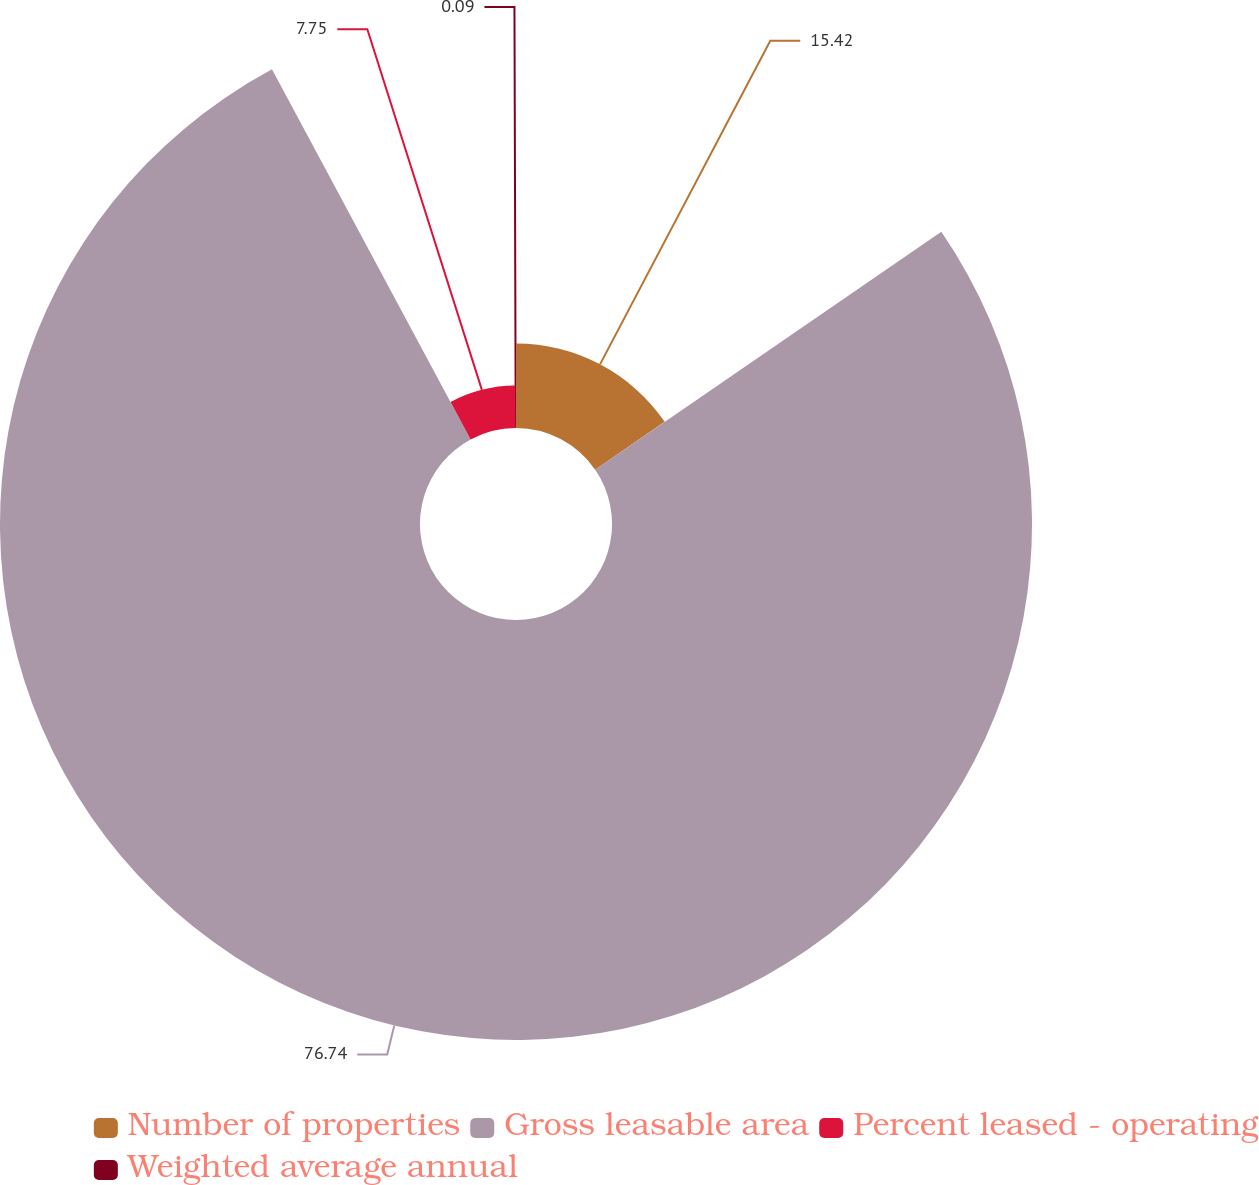Convert chart to OTSL. <chart><loc_0><loc_0><loc_500><loc_500><pie_chart><fcel>Number of properties<fcel>Gross leasable area<fcel>Percent leased - operating<fcel>Weighted average annual<nl><fcel>15.42%<fcel>76.74%<fcel>7.75%<fcel>0.09%<nl></chart> 